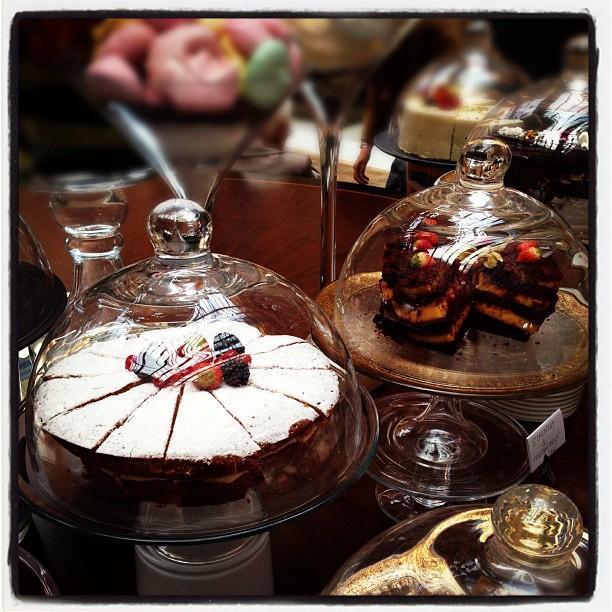Verify the accuracy of this image caption: "The bowl is at the edge of the dining table.".
Answer yes or no. No. 